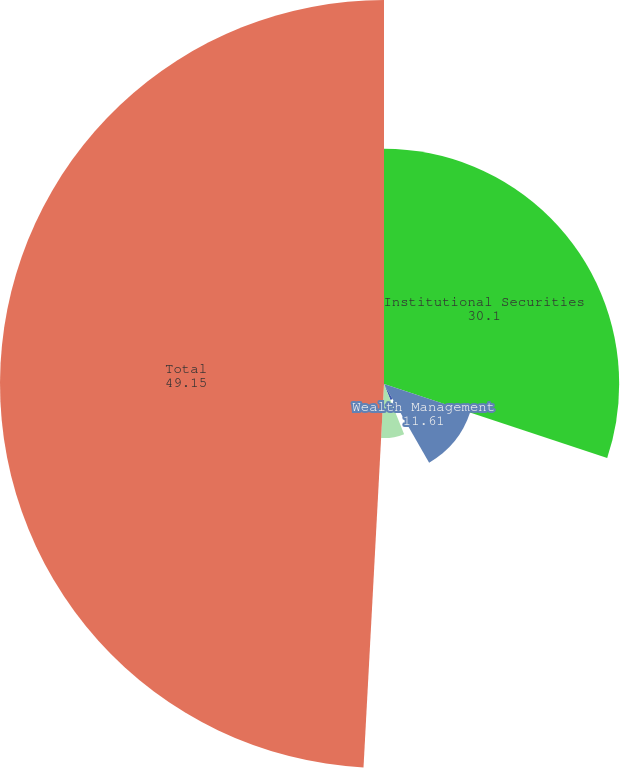<chart> <loc_0><loc_0><loc_500><loc_500><pie_chart><fcel>Institutional Securities<fcel>Wealth Management<fcel>Investment Management<fcel>Parent capital(1)<fcel>Total<nl><fcel>30.1%<fcel>11.61%<fcel>2.22%<fcel>6.92%<fcel>49.15%<nl></chart> 